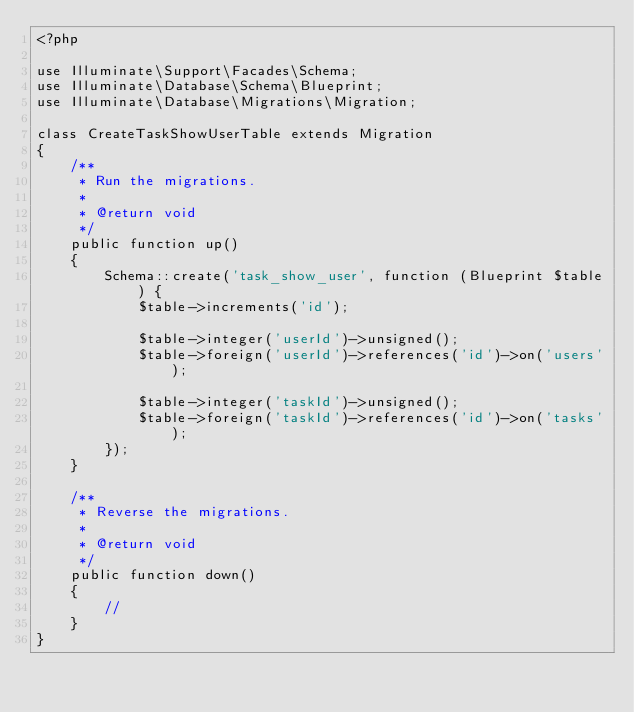<code> <loc_0><loc_0><loc_500><loc_500><_PHP_><?php

use Illuminate\Support\Facades\Schema;
use Illuminate\Database\Schema\Blueprint;
use Illuminate\Database\Migrations\Migration;

class CreateTaskShowUserTable extends Migration
{
    /**
     * Run the migrations.
     *
     * @return void
     */
    public function up()
    {
        Schema::create('task_show_user', function (Blueprint $table) {
            $table->increments('id');

            $table->integer('userId')->unsigned();
            $table->foreign('userId')->references('id')->on('users');

            $table->integer('taskId')->unsigned();
            $table->foreign('taskId')->references('id')->on('tasks');
        });
    }

    /**
     * Reverse the migrations.
     *
     * @return void
     */
    public function down()
    {
        //
    }
}
</code> 